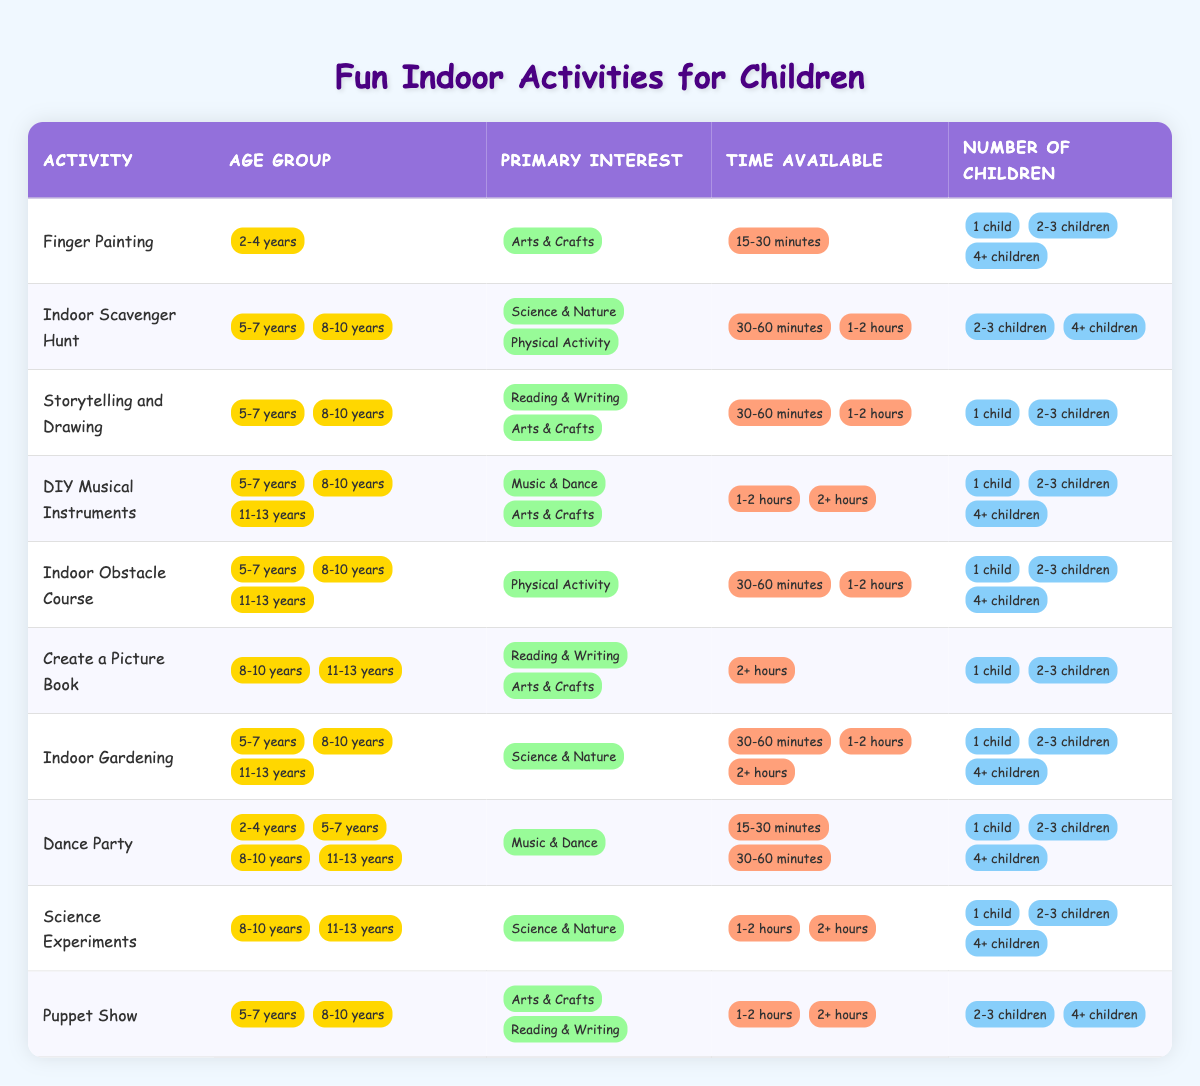What indoor activity is suitable for children aged 2-4 years who are interested in Arts & Crafts and have 15-30 minutes available? From the table, "Finger Painting" is listed under the age group of 2-4 years, focuses on Arts & Crafts, and requires 15-30 minutes.
Answer: Finger Painting Is "Dance Party" an activity that can accommodate 4 or more children? Yes, the table indicates that "Dance Party" can be suitable for 1 child, 2-3 children, and 4+ children.
Answer: Yes How many activities are suitable for children aged 5-7 years that are focused on Science & Nature? Looking at the table, there is only one activity listed for the age group 5-7 years which is “Indoor Scavenger Hunt,” and it focuses on Science & Nature.
Answer: 1 What is the longest time required for activities that involve reading and writing for children aged 8-10 years? The activity "Create a Picture Book" for ages 8-10 years requires more than 2 hours, which is the longest time noted for activities in the reading and writing category.
Answer: 2+ hours Are there any activities suitable for 11-13 year olds that focus on music and dance? Reviewing the table, there are no activities listed for the age group 11-13 years that specifically mention music and dance.
Answer: No What indoor activity has the highest age range and also requires at least 2+ hours? The activity "Create a Picture Book" is suitable for ages 8-10 years and 11-13 years, and it requires at least 2+ hours of time.
Answer: Create a Picture Book How many total activities are available for children aged 5-7 years? By counting the rows in the table, there are five activities available for the age group 5-7 years: "Indoor Scavenger Hunt," "Storytelling and Drawing," "DIY Musical Instruments," "Indoor Obstacle Course," and "Dance Party."
Answer: 5 Which activity can you do for 30-60 minutes with 2-3 children and is related to Arts & Crafts? "Storytelling and Drawing" is suitable for 30-60 minutes, allows for 2-3 children, and relates to Arts & Crafts.
Answer: Storytelling and Drawing 